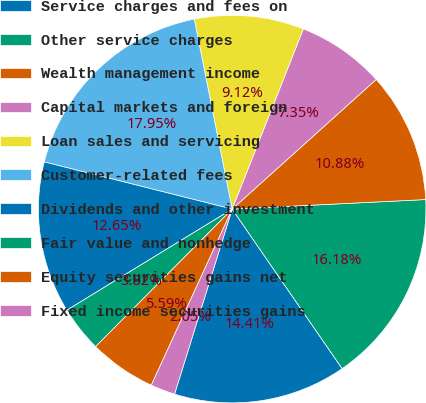<chart> <loc_0><loc_0><loc_500><loc_500><pie_chart><fcel>Service charges and fees on<fcel>Other service charges<fcel>Wealth management income<fcel>Capital markets and foreign<fcel>Loan sales and servicing<fcel>Customer-related fees<fcel>Dividends and other investment<fcel>Fair value and nonhedge<fcel>Equity securities gains net<fcel>Fixed income securities gains<nl><fcel>14.41%<fcel>16.18%<fcel>10.88%<fcel>7.35%<fcel>9.12%<fcel>17.95%<fcel>12.65%<fcel>3.82%<fcel>5.59%<fcel>2.05%<nl></chart> 